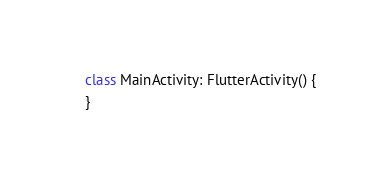<code> <loc_0><loc_0><loc_500><loc_500><_Kotlin_>
class MainActivity: FlutterActivity() {
}
</code> 